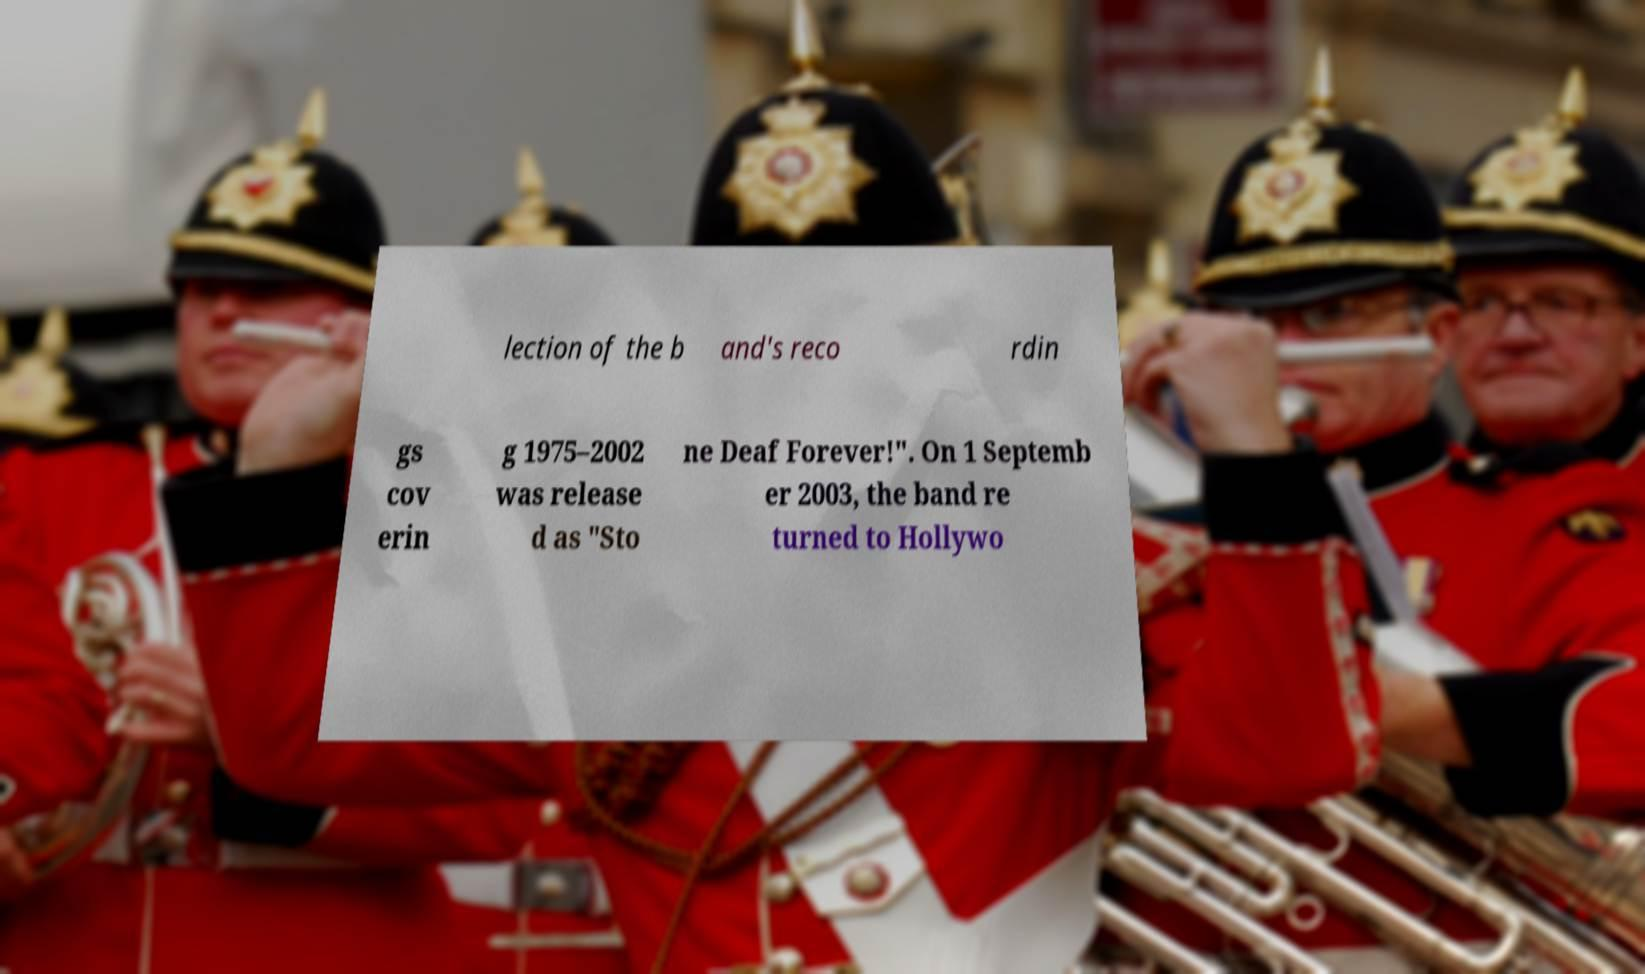I need the written content from this picture converted into text. Can you do that? lection of the b and's reco rdin gs cov erin g 1975–2002 was release d as "Sto ne Deaf Forever!". On 1 Septemb er 2003, the band re turned to Hollywo 